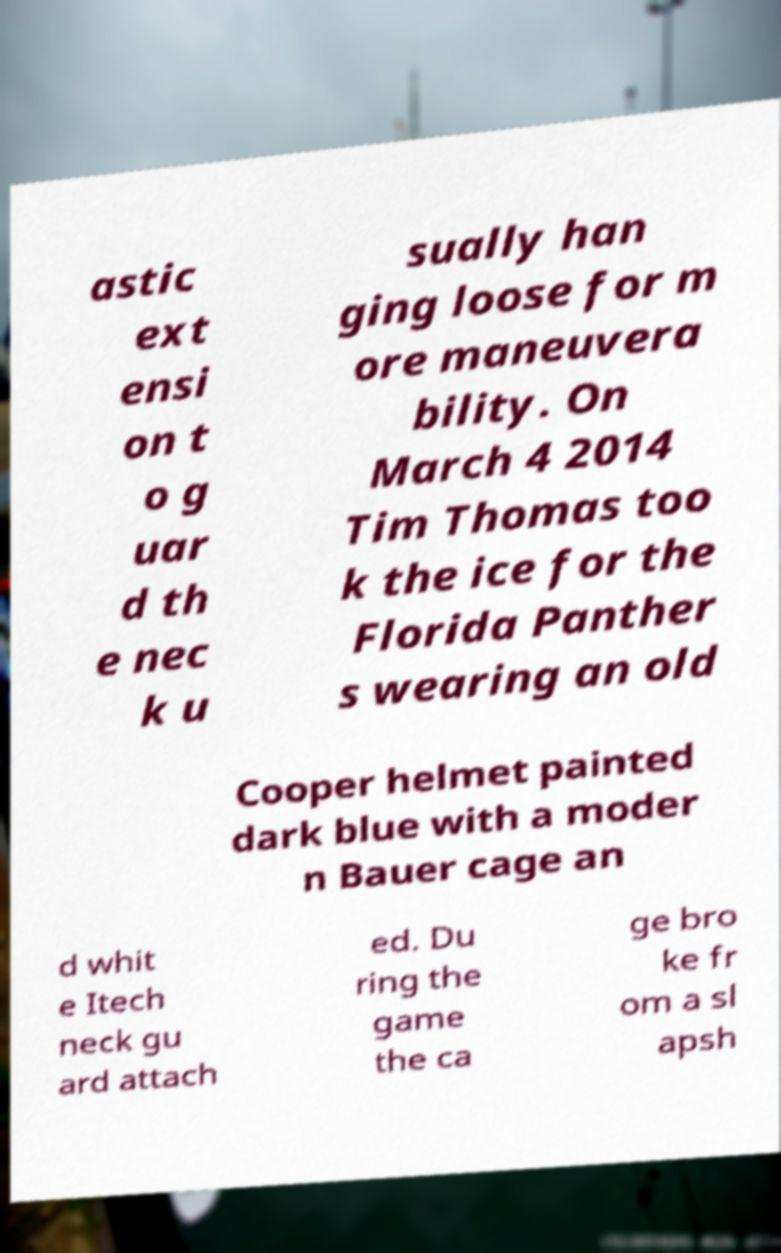Please read and relay the text visible in this image. What does it say? astic ext ensi on t o g uar d th e nec k u sually han ging loose for m ore maneuvera bility. On March 4 2014 Tim Thomas too k the ice for the Florida Panther s wearing an old Cooper helmet painted dark blue with a moder n Bauer cage an d whit e Itech neck gu ard attach ed. Du ring the game the ca ge bro ke fr om a sl apsh 